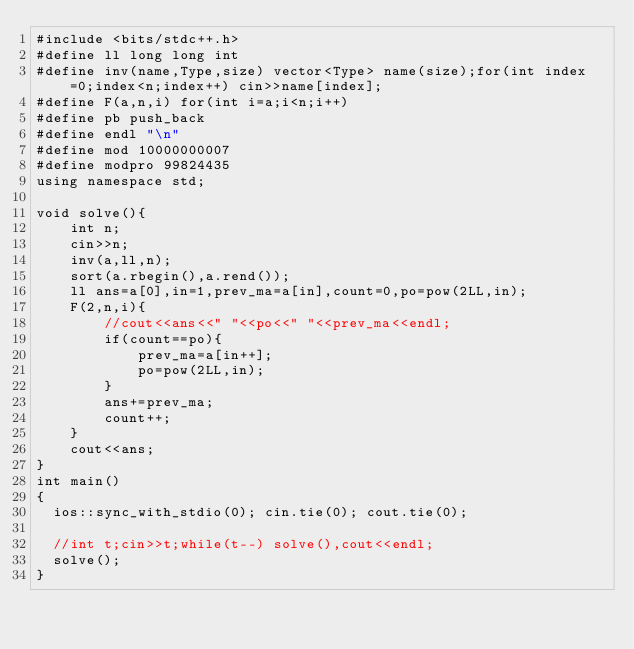<code> <loc_0><loc_0><loc_500><loc_500><_C++_>#include <bits/stdc++.h>
#define ll long long int
#define inv(name,Type,size) vector<Type> name(size);for(int index=0;index<n;index++) cin>>name[index];
#define F(a,n,i) for(int i=a;i<n;i++)
#define pb push_back
#define endl "\n"
#define mod 10000000007
#define modpro 99824435
using namespace std;

void solve(){
	int n;
	cin>>n;
	inv(a,ll,n);
	sort(a.rbegin(),a.rend());
	ll ans=a[0],in=1,prev_ma=a[in],count=0,po=pow(2LL,in);
	F(2,n,i){
		//cout<<ans<<" "<<po<<" "<<prev_ma<<endl;
		if(count==po){
			prev_ma=a[in++];
			po=pow(2LL,in);
		}
		ans+=prev_ma;
		count++;
	}
	cout<<ans;
}
int main()
{
  ios::sync_with_stdio(0); cin.tie(0); cout.tie(0);
  
  //int t;cin>>t;while(t--) solve(),cout<<endl;
  solve();
}

</code> 